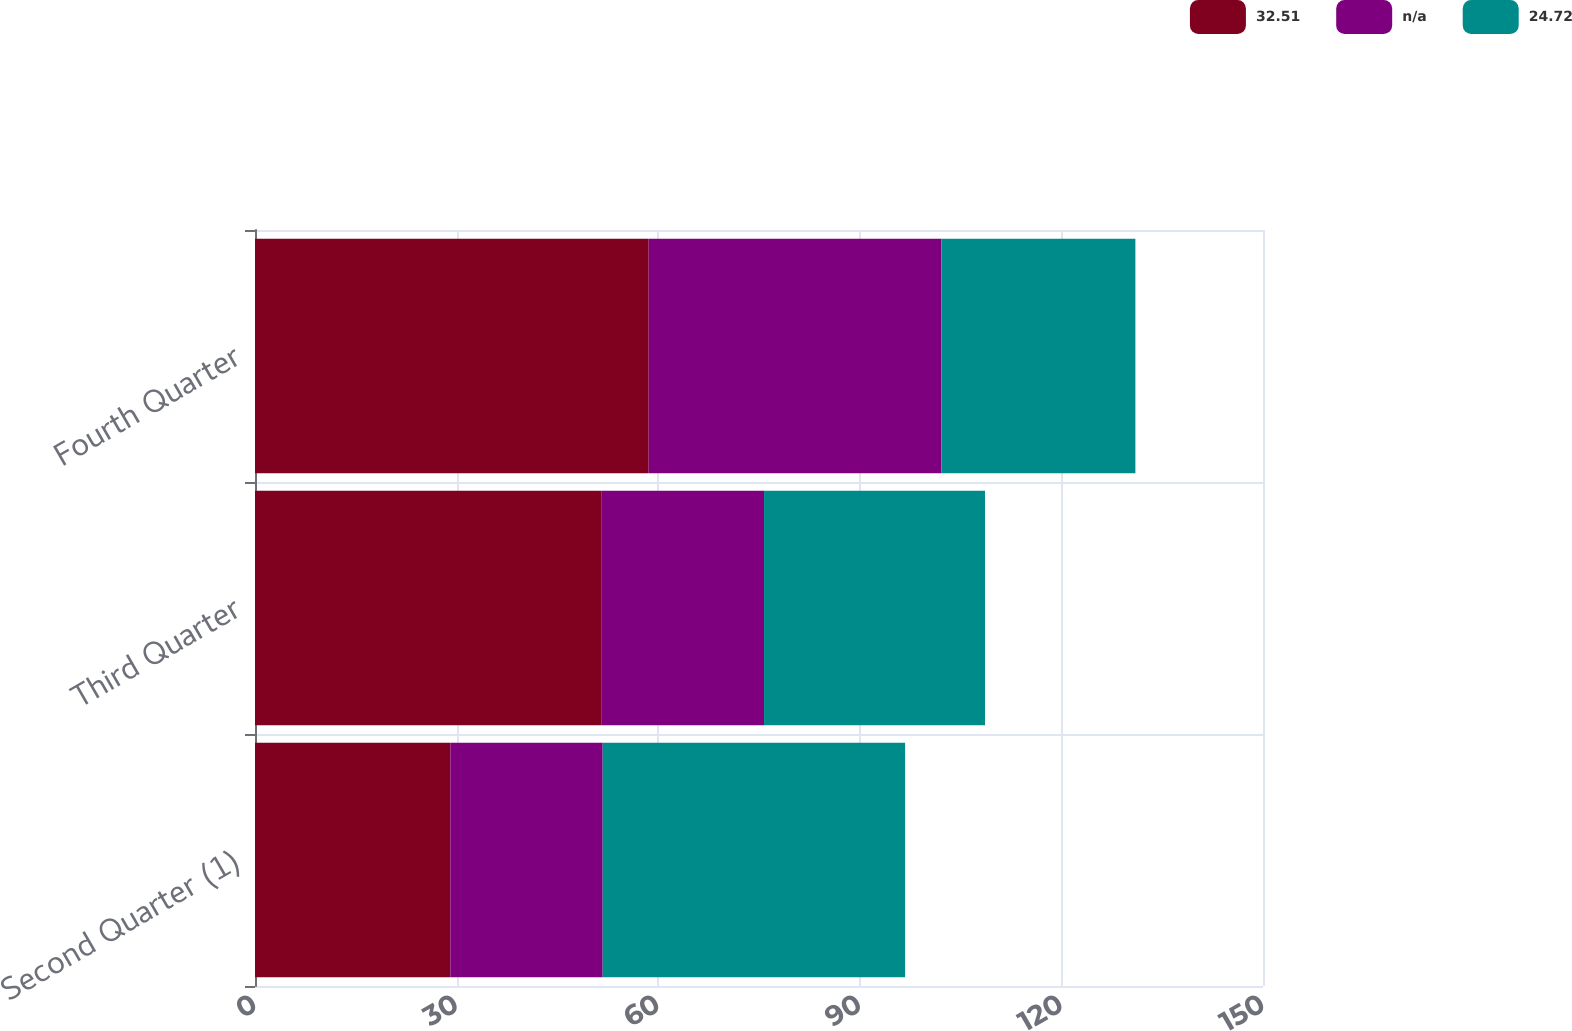Convert chart. <chart><loc_0><loc_0><loc_500><loc_500><stacked_bar_chart><ecel><fcel>Second Quarter (1)<fcel>Third Quarter<fcel>Fourth Quarter<nl><fcel>32.51<fcel>29.07<fcel>51.6<fcel>58.58<nl><fcel>nan<fcel>22.67<fcel>24.15<fcel>43.55<nl><fcel>24.72<fcel>45<fcel>32.88<fcel>28.88<nl></chart> 